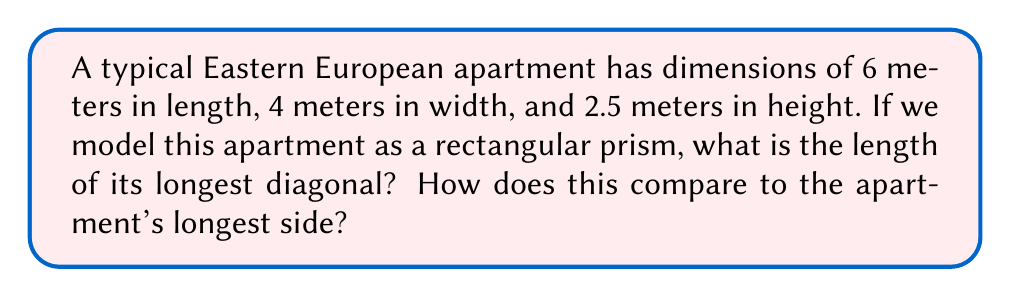Solve this math problem. To solve this problem, we'll follow these steps:

1) The diagonal of a rectangular prism can be calculated using the formula:

   $$d = \sqrt{l^2 + w^2 + h^2}$$

   Where $d$ is the diagonal, $l$ is length, $w$ is width, and $h$ is height.

2) Let's substitute the given dimensions:
   $l = 6$ m, $w = 4$ m, $h = 2.5$ m

3) Now, let's calculate:

   $$d = \sqrt{6^2 + 4^2 + 2.5^2}$$
   $$d = \sqrt{36 + 16 + 6.25}$$
   $$d = \sqrt{58.25}$$
   $$d \approx 7.63 \text{ m}$$

4) To compare with the apartment's longest side (6 m):

   $$7.63 \text{ m} - 6 \text{ m} = 1.63 \text{ m}$$

   The diagonal is about 1.63 meters longer than the longest side.

5) To express this as a percentage increase:

   $$\frac{1.63}{6} \times 100\% \approx 27.17\%$$

[asy]
import three;

size(200);
currentprojection=perspective(6,3,2);

draw(box((0,0,0),(6,4,2.5)));
draw((0,0,0)--(6,4,2.5),red);

label("6m",(3,0,0),S);
label("4m",(6,2,0),E);
label("2.5m",(6,4,1.25),N);
label("7.63m",(3,2,1.25),NW);
[/asy]
Answer: 7.63 m; 27.17% longer than the longest side 